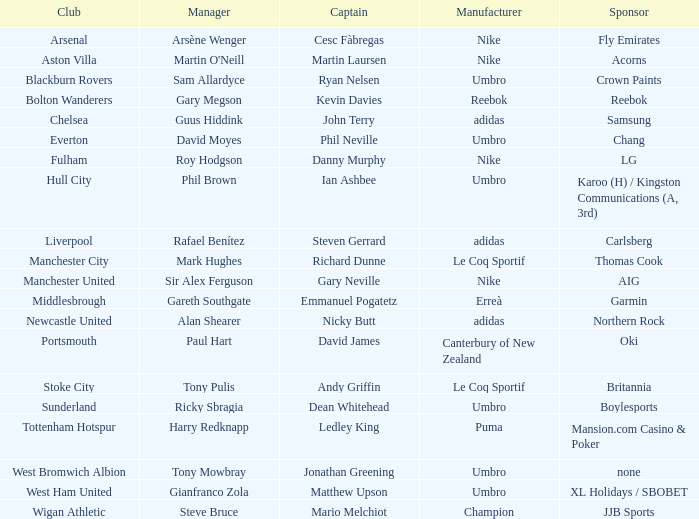Who is the captain of Middlesbrough? Emmanuel Pogatetz. 